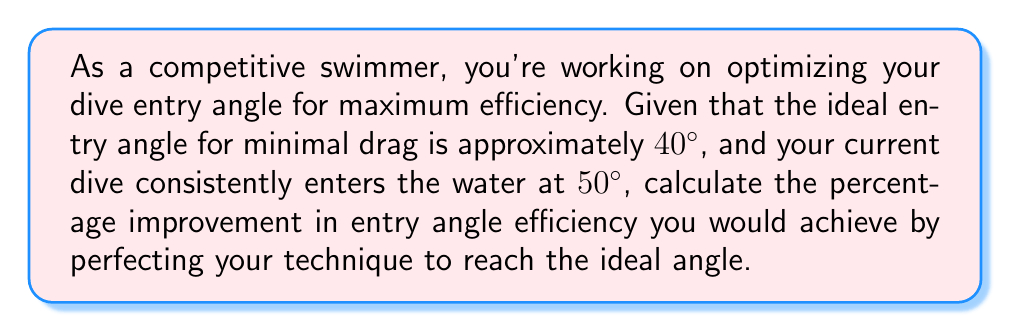Teach me how to tackle this problem. To solve this problem, we need to consider the difference between the current angle and the ideal angle, then calculate the percentage improvement. Let's break it down step-by-step:

1) First, let's define our variables:
   $\theta_i$ = ideal angle = 40°
   $\theta_c$ = current angle = 50°

2) The difference between the current angle and the ideal angle is:
   $\Delta\theta = \theta_c - \theta_i = 50° - 40° = 10°$

3) To calculate the percentage improvement, we need to express this difference as a percentage of the current angle:

   Percentage Improvement = $\frac{\Delta\theta}{\theta_c} \times 100\%$

4) Substituting our values:

   Percentage Improvement = $\frac{10°}{50°} \times 100\%$

5) Simplifying:
   
   Percentage Improvement = $0.2 \times 100\% = 20\%$

Therefore, by perfecting your technique to achieve the ideal entry angle, you would improve your entry angle efficiency by 20%.
Answer: 20% 